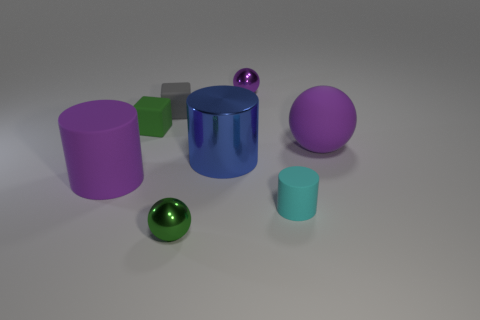Is there a tiny cyan matte object that has the same shape as the blue metal object?
Offer a terse response. Yes. There is a green object that is behind the rubber cylinder that is in front of the large rubber cylinder; what is its shape?
Ensure brevity in your answer.  Cube. What shape is the small cyan thing?
Offer a terse response. Cylinder. There is a green object behind the big purple matte object that is on the right side of the green thing behind the small cylinder; what is it made of?
Offer a terse response. Rubber. What number of other things are made of the same material as the big blue cylinder?
Your answer should be compact. 2. There is a matte cylinder behind the tiny cyan thing; how many tiny purple things are left of it?
Offer a terse response. 0. How many balls are green shiny objects or blue shiny objects?
Provide a short and direct response. 1. The ball that is behind the green shiny ball and in front of the tiny purple thing is what color?
Give a very brief answer. Purple. Is there anything else that has the same color as the big metal cylinder?
Ensure brevity in your answer.  No. There is a large matte thing that is in front of the matte object that is right of the small matte cylinder; what is its color?
Ensure brevity in your answer.  Purple. 